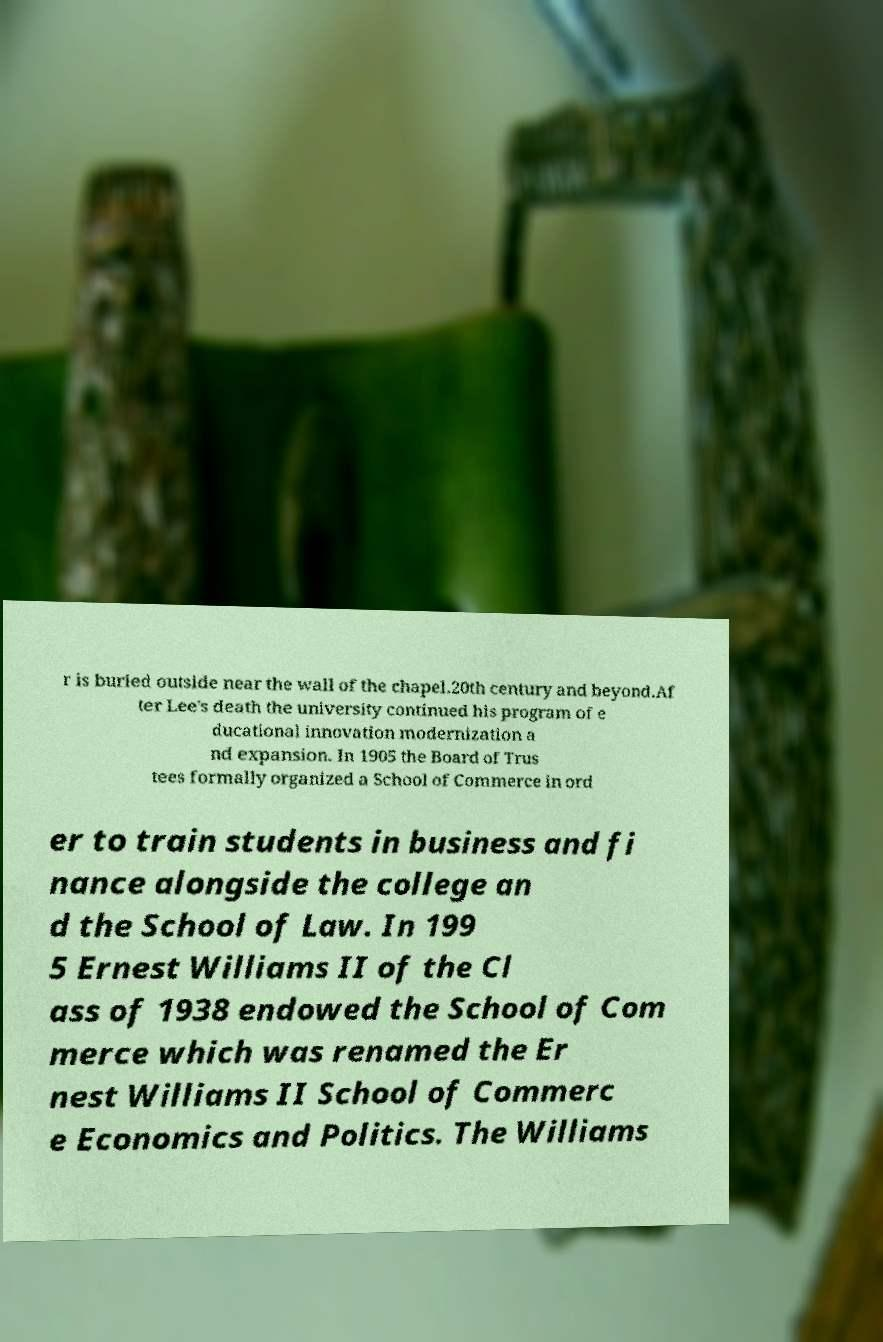Could you assist in decoding the text presented in this image and type it out clearly? r is buried outside near the wall of the chapel.20th century and beyond.Af ter Lee's death the university continued his program of e ducational innovation modernization a nd expansion. In 1905 the Board of Trus tees formally organized a School of Commerce in ord er to train students in business and fi nance alongside the college an d the School of Law. In 199 5 Ernest Williams II of the Cl ass of 1938 endowed the School of Com merce which was renamed the Er nest Williams II School of Commerc e Economics and Politics. The Williams 